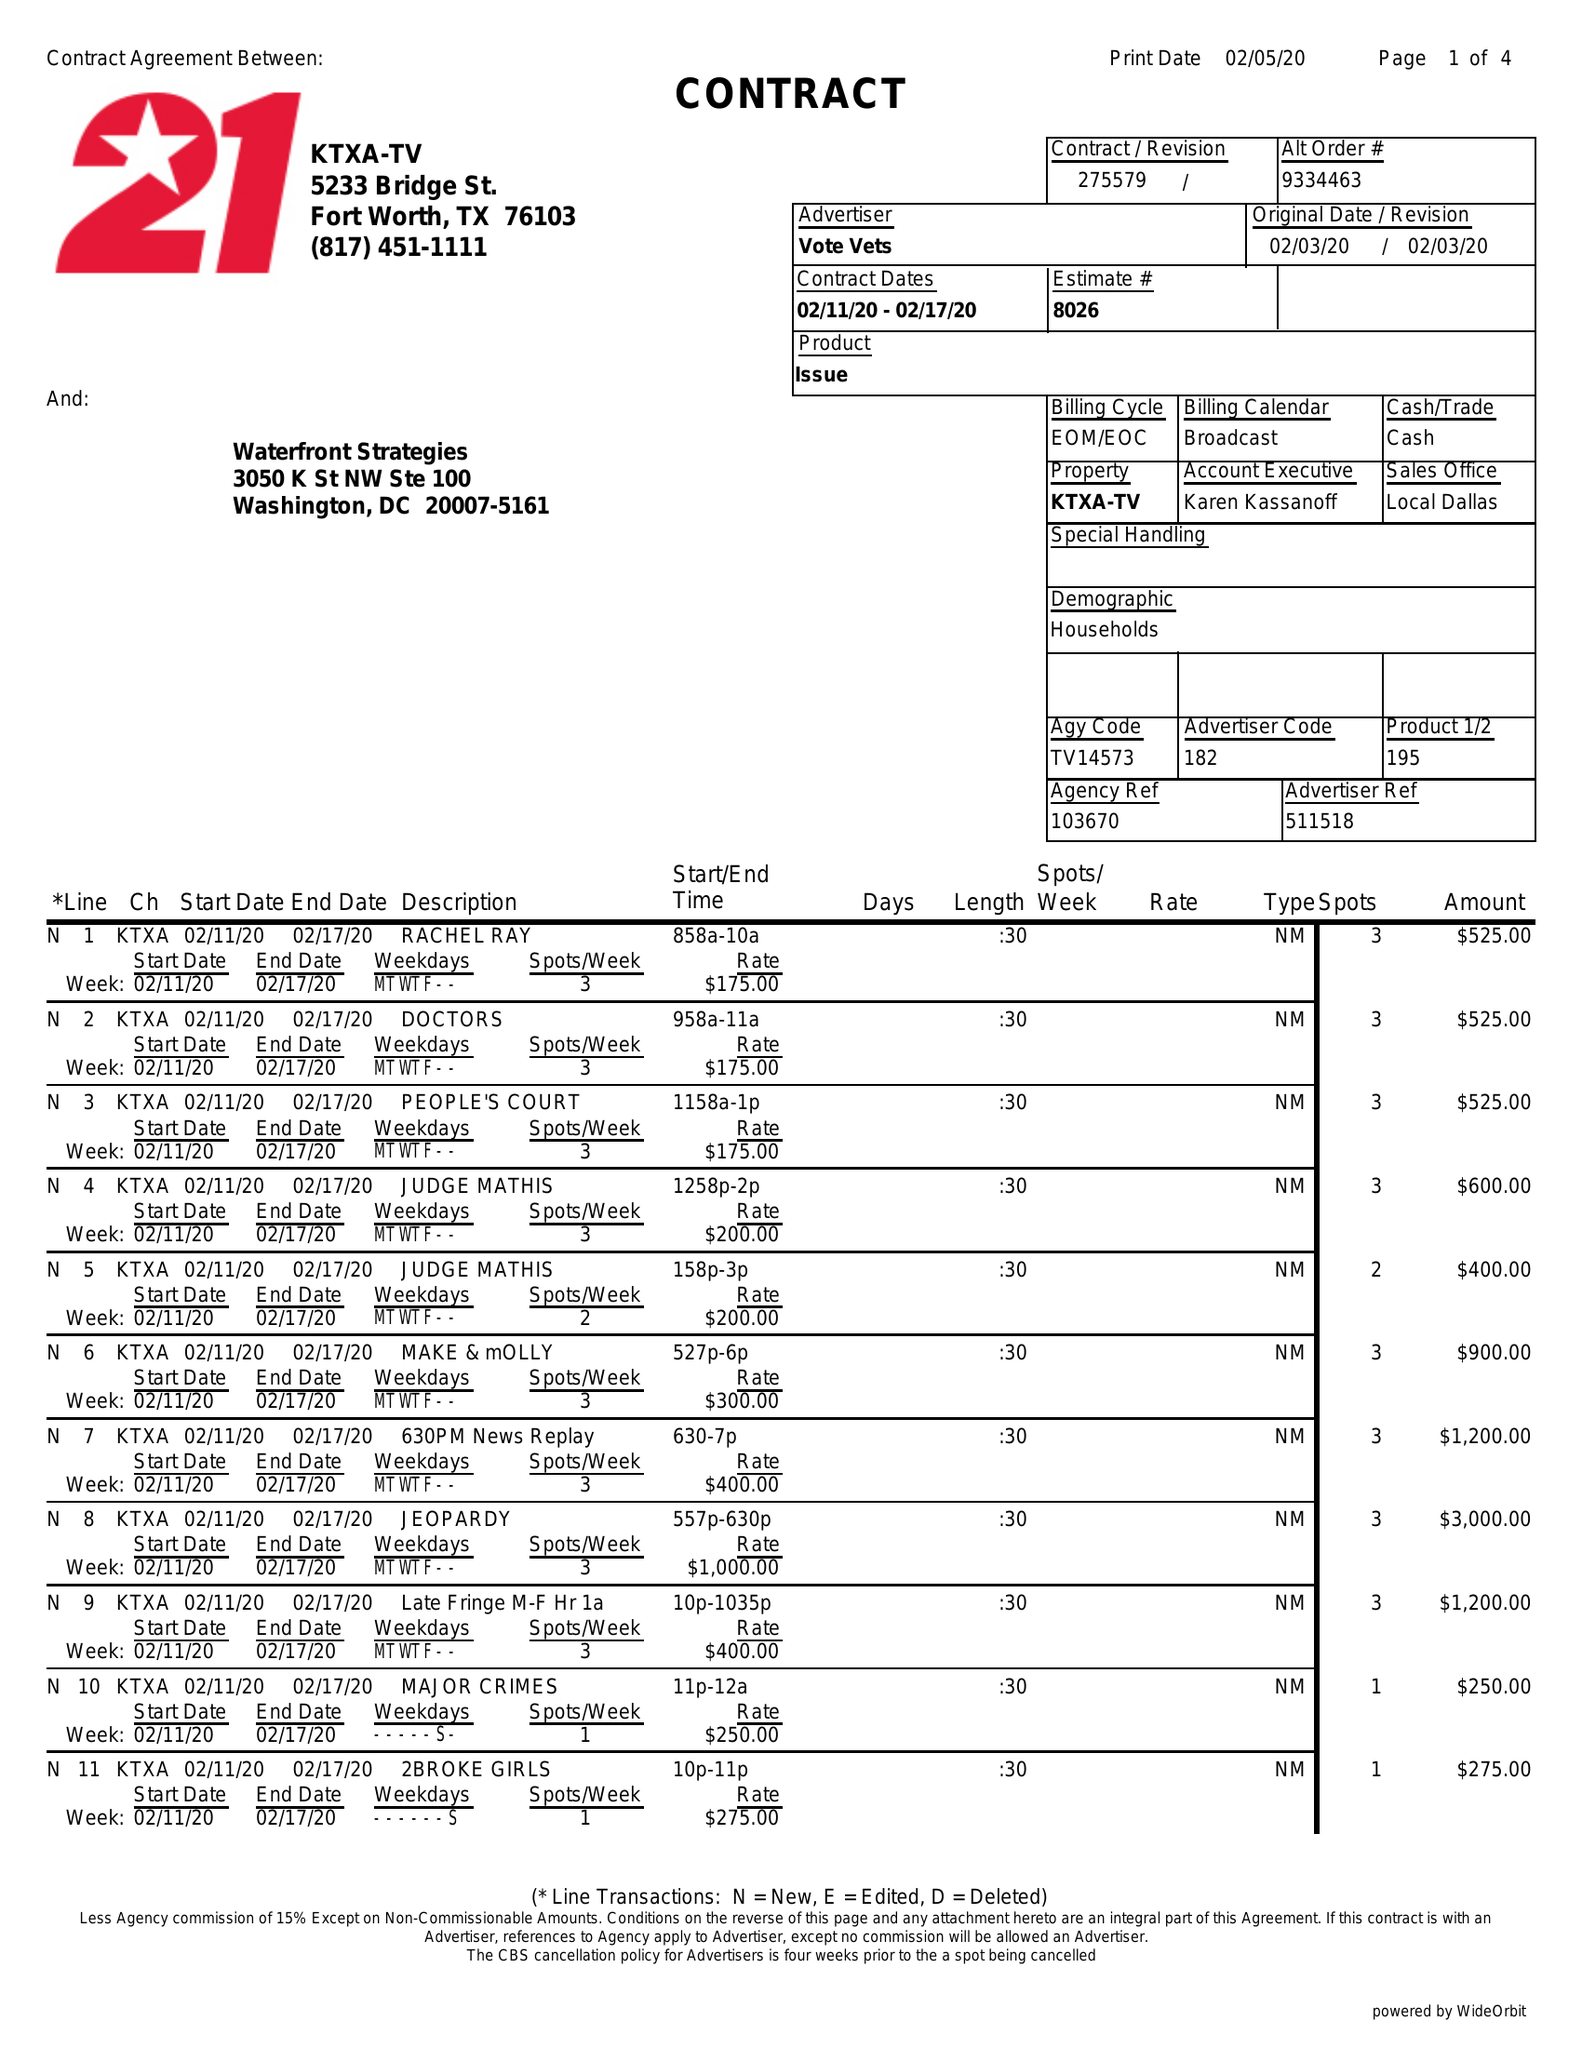What is the value for the contract_num?
Answer the question using a single word or phrase. 275579 